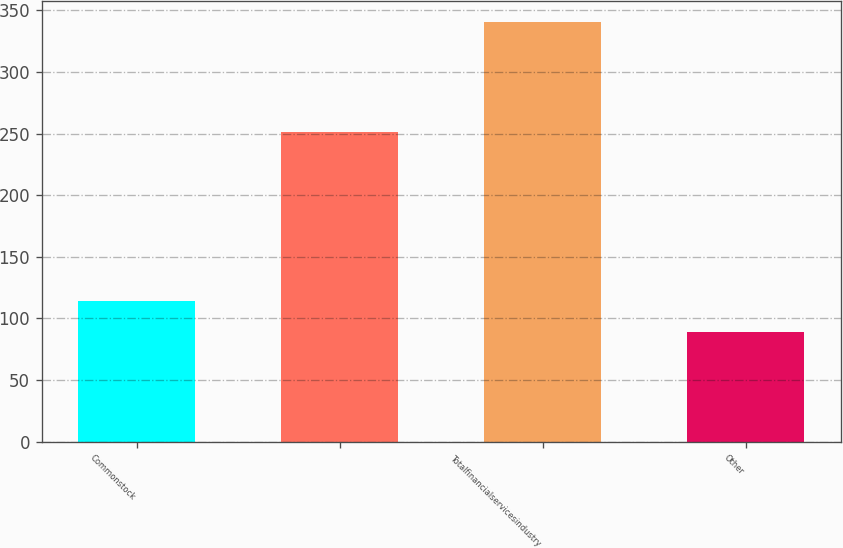Convert chart to OTSL. <chart><loc_0><loc_0><loc_500><loc_500><bar_chart><fcel>Commonstock<fcel>Unnamed: 1<fcel>Totalfinancialservicesindustry<fcel>Other<nl><fcel>114.2<fcel>251<fcel>341<fcel>89<nl></chart> 